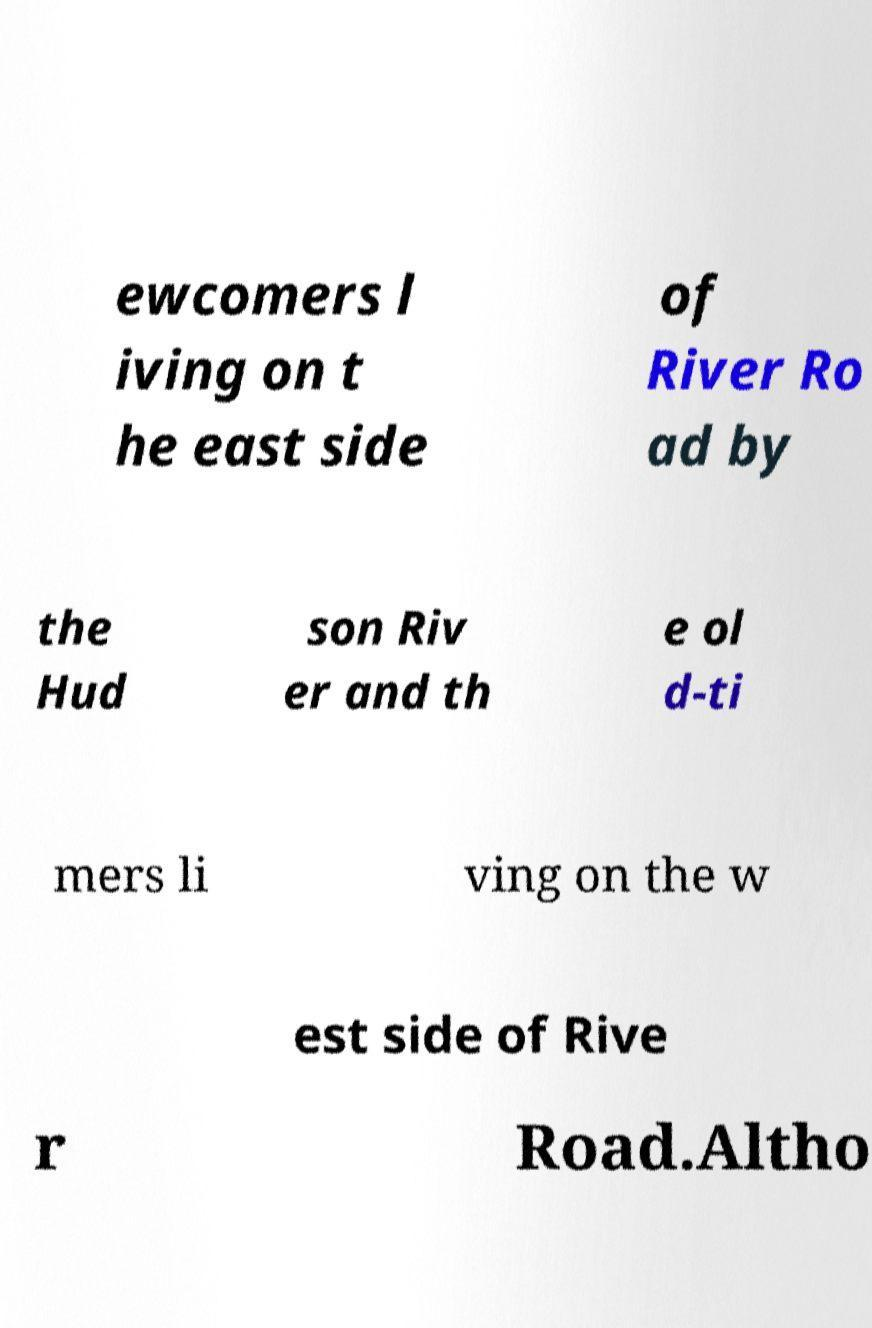I need the written content from this picture converted into text. Can you do that? ewcomers l iving on t he east side of River Ro ad by the Hud son Riv er and th e ol d-ti mers li ving on the w est side of Rive r Road.Altho 